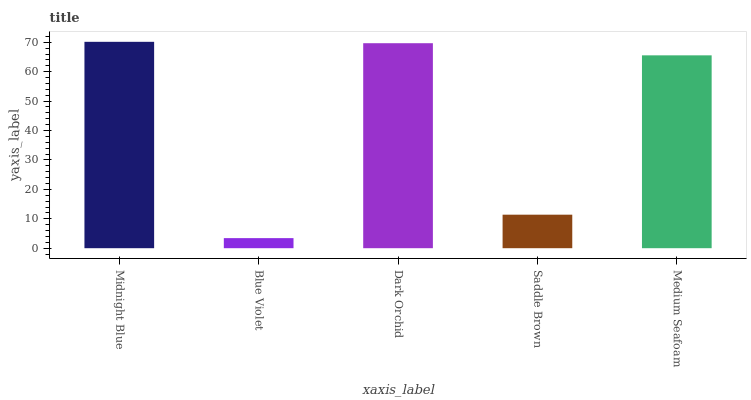Is Blue Violet the minimum?
Answer yes or no. Yes. Is Midnight Blue the maximum?
Answer yes or no. Yes. Is Dark Orchid the minimum?
Answer yes or no. No. Is Dark Orchid the maximum?
Answer yes or no. No. Is Dark Orchid greater than Blue Violet?
Answer yes or no. Yes. Is Blue Violet less than Dark Orchid?
Answer yes or no. Yes. Is Blue Violet greater than Dark Orchid?
Answer yes or no. No. Is Dark Orchid less than Blue Violet?
Answer yes or no. No. Is Medium Seafoam the high median?
Answer yes or no. Yes. Is Medium Seafoam the low median?
Answer yes or no. Yes. Is Midnight Blue the high median?
Answer yes or no. No. Is Dark Orchid the low median?
Answer yes or no. No. 